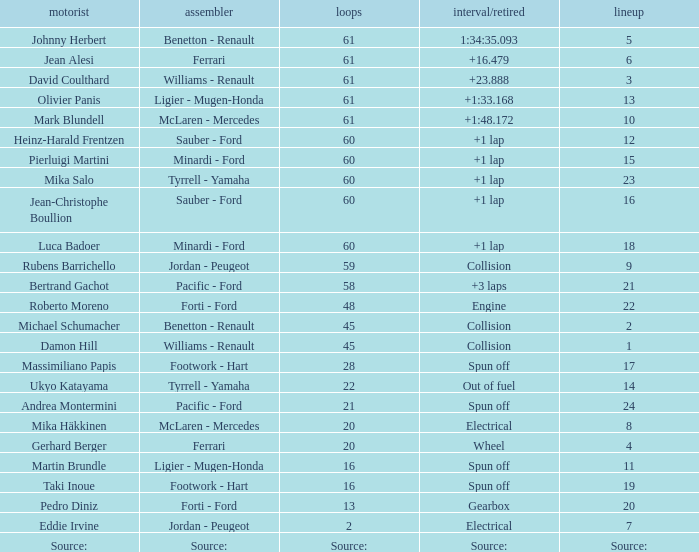What's the time/retired for constructor source:? Source:. Would you mind parsing the complete table? {'header': ['motorist', 'assembler', 'loops', 'interval/retired', 'lineup'], 'rows': [['Johnny Herbert', 'Benetton - Renault', '61', '1:34:35.093', '5'], ['Jean Alesi', 'Ferrari', '61', '+16.479', '6'], ['David Coulthard', 'Williams - Renault', '61', '+23.888', '3'], ['Olivier Panis', 'Ligier - Mugen-Honda', '61', '+1:33.168', '13'], ['Mark Blundell', 'McLaren - Mercedes', '61', '+1:48.172', '10'], ['Heinz-Harald Frentzen', 'Sauber - Ford', '60', '+1 lap', '12'], ['Pierluigi Martini', 'Minardi - Ford', '60', '+1 lap', '15'], ['Mika Salo', 'Tyrrell - Yamaha', '60', '+1 lap', '23'], ['Jean-Christophe Boullion', 'Sauber - Ford', '60', '+1 lap', '16'], ['Luca Badoer', 'Minardi - Ford', '60', '+1 lap', '18'], ['Rubens Barrichello', 'Jordan - Peugeot', '59', 'Collision', '9'], ['Bertrand Gachot', 'Pacific - Ford', '58', '+3 laps', '21'], ['Roberto Moreno', 'Forti - Ford', '48', 'Engine', '22'], ['Michael Schumacher', 'Benetton - Renault', '45', 'Collision', '2'], ['Damon Hill', 'Williams - Renault', '45', 'Collision', '1'], ['Massimiliano Papis', 'Footwork - Hart', '28', 'Spun off', '17'], ['Ukyo Katayama', 'Tyrrell - Yamaha', '22', 'Out of fuel', '14'], ['Andrea Montermini', 'Pacific - Ford', '21', 'Spun off', '24'], ['Mika Häkkinen', 'McLaren - Mercedes', '20', 'Electrical', '8'], ['Gerhard Berger', 'Ferrari', '20', 'Wheel', '4'], ['Martin Brundle', 'Ligier - Mugen-Honda', '16', 'Spun off', '11'], ['Taki Inoue', 'Footwork - Hart', '16', 'Spun off', '19'], ['Pedro Diniz', 'Forti - Ford', '13', 'Gearbox', '20'], ['Eddie Irvine', 'Jordan - Peugeot', '2', 'Electrical', '7'], ['Source:', 'Source:', 'Source:', 'Source:', 'Source:']]} 